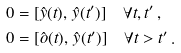Convert formula to latex. <formula><loc_0><loc_0><loc_500><loc_500>0 & = [ \hat { y } ( t ) , \, \hat { y } ( t ^ { \prime } ) ] \quad \forall t , t ^ { \prime } \, , \\ 0 & = [ \hat { o } ( t ) , \, \hat { y } ( t ^ { \prime } ) ] \quad \forall t > t ^ { \prime } \, .</formula> 